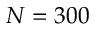<formula> <loc_0><loc_0><loc_500><loc_500>N = 3 0 0</formula> 